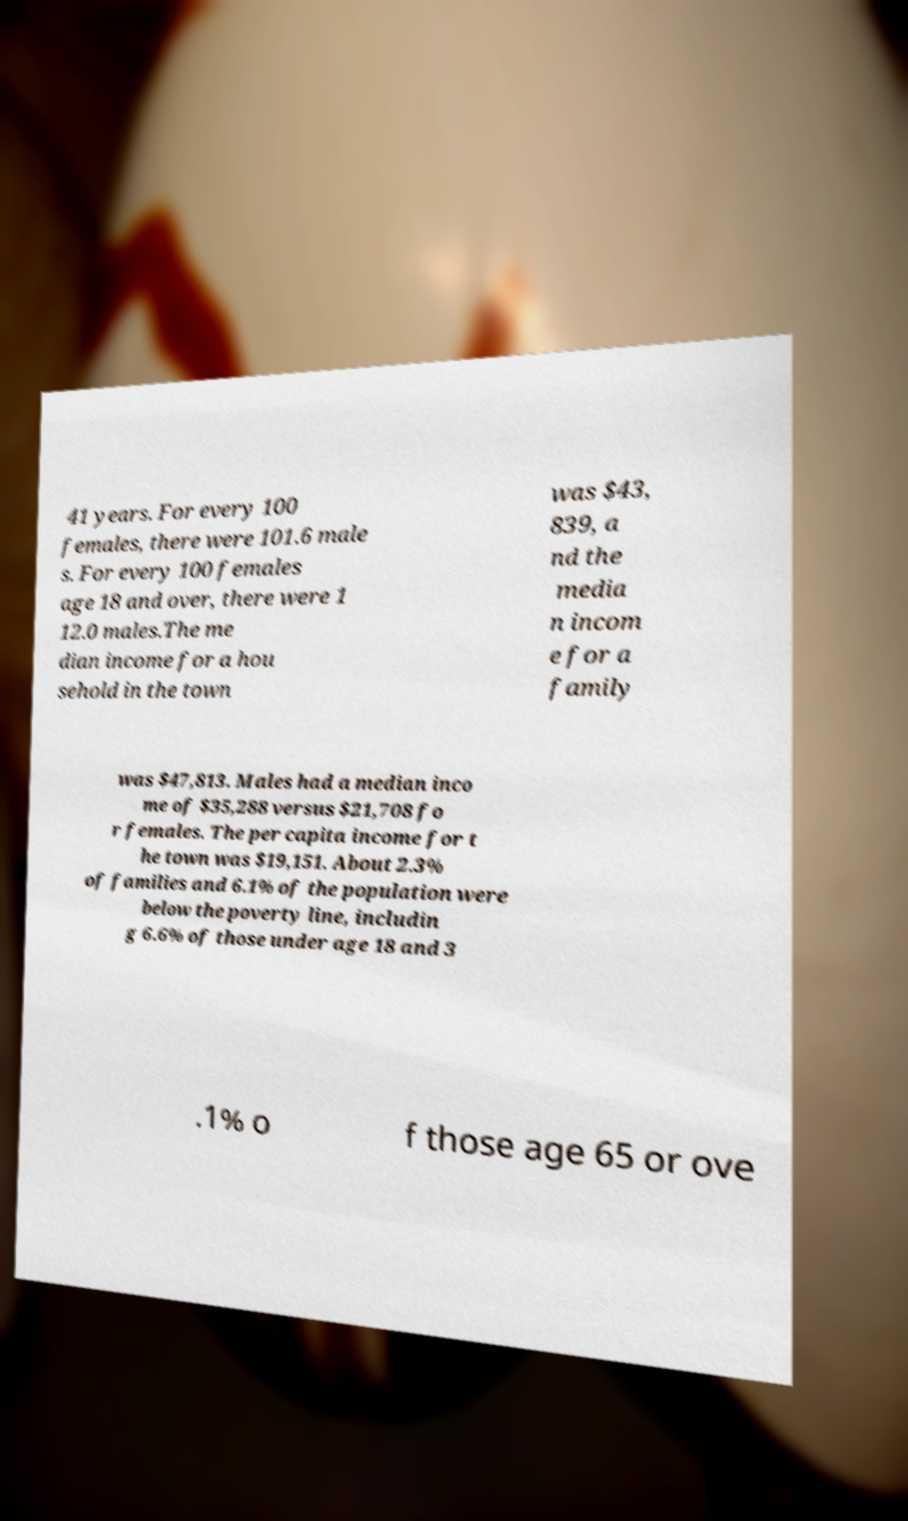Could you assist in decoding the text presented in this image and type it out clearly? 41 years. For every 100 females, there were 101.6 male s. For every 100 females age 18 and over, there were 1 12.0 males.The me dian income for a hou sehold in the town was $43, 839, a nd the media n incom e for a family was $47,813. Males had a median inco me of $35,288 versus $21,708 fo r females. The per capita income for t he town was $19,151. About 2.3% of families and 6.1% of the population were below the poverty line, includin g 6.6% of those under age 18 and 3 .1% o f those age 65 or ove 